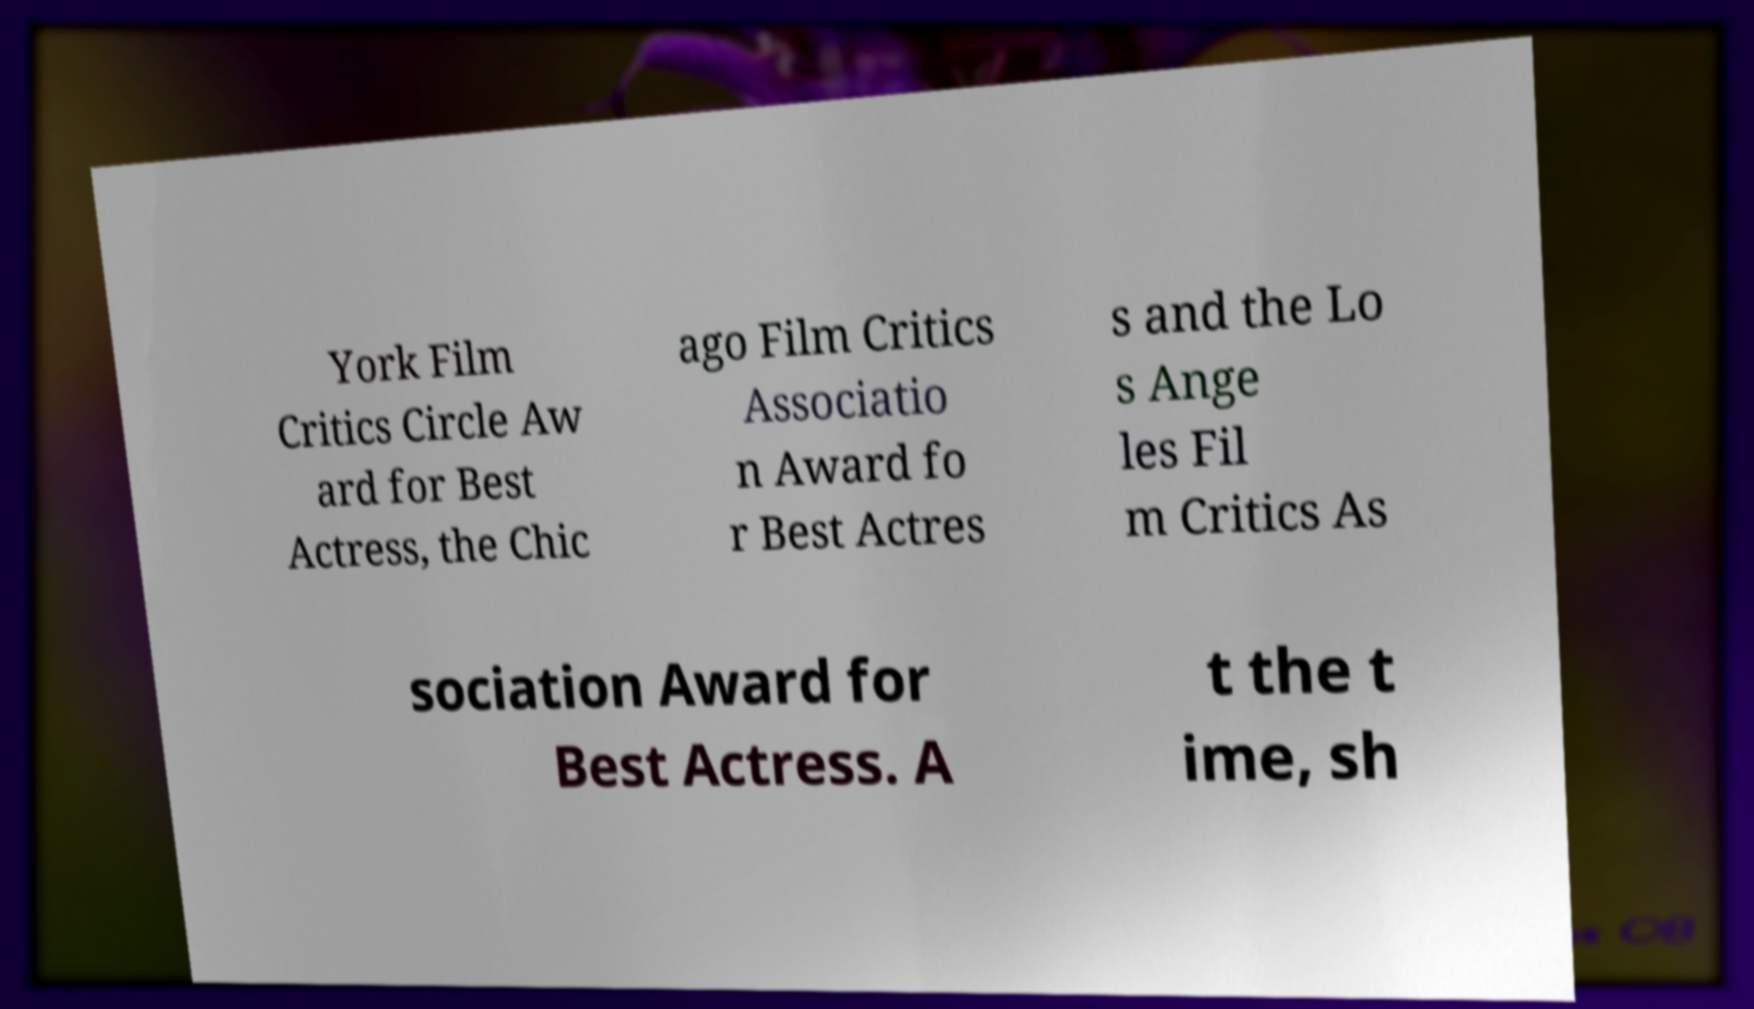Could you extract and type out the text from this image? York Film Critics Circle Aw ard for Best Actress, the Chic ago Film Critics Associatio n Award fo r Best Actres s and the Lo s Ange les Fil m Critics As sociation Award for Best Actress. A t the t ime, sh 